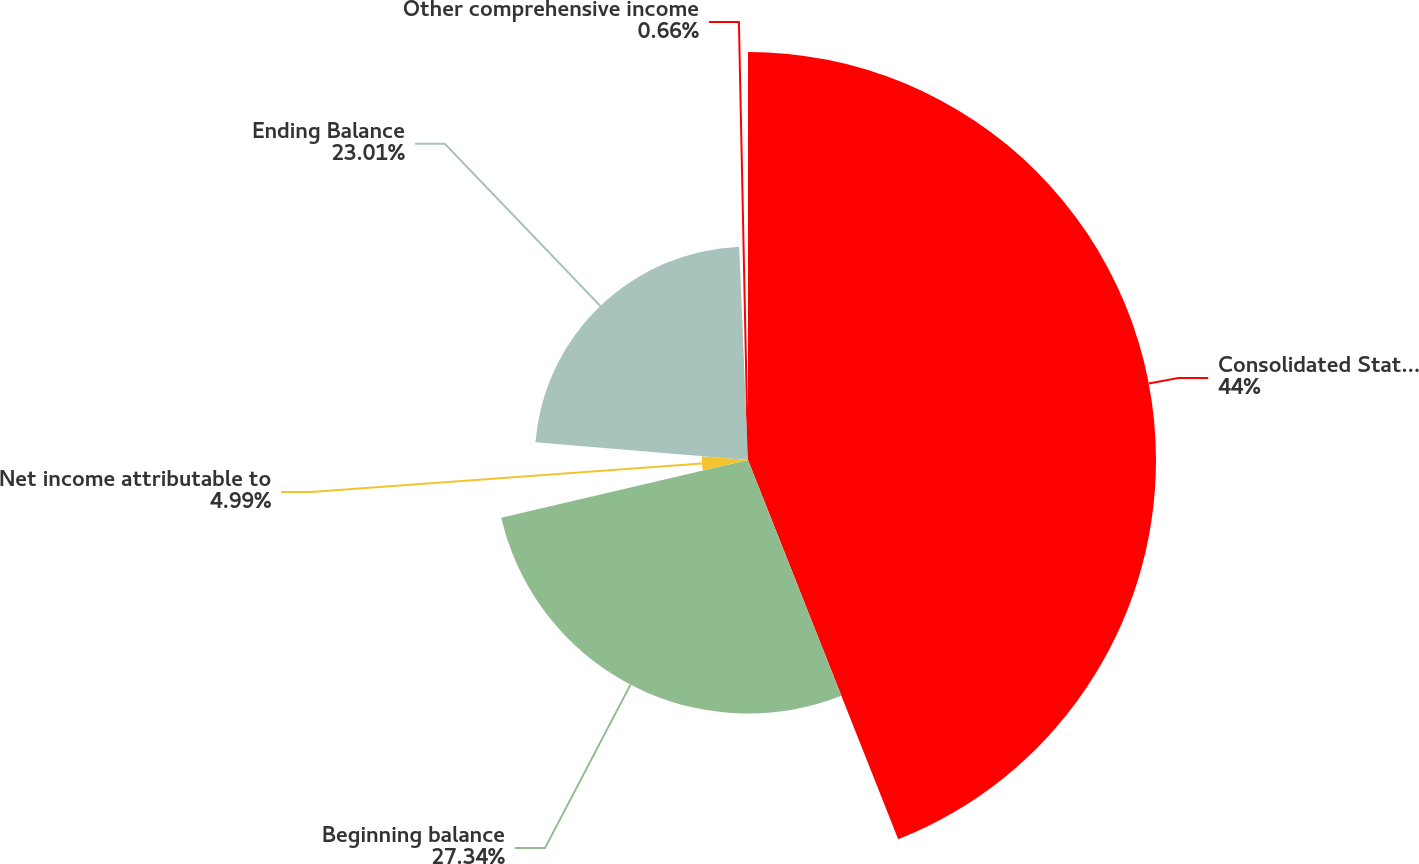Convert chart to OTSL. <chart><loc_0><loc_0><loc_500><loc_500><pie_chart><fcel>Consolidated Statement of<fcel>Beginning balance<fcel>Net income attributable to<fcel>Ending Balance<fcel>Other comprehensive income<nl><fcel>44.0%<fcel>27.34%<fcel>4.99%<fcel>23.01%<fcel>0.66%<nl></chart> 